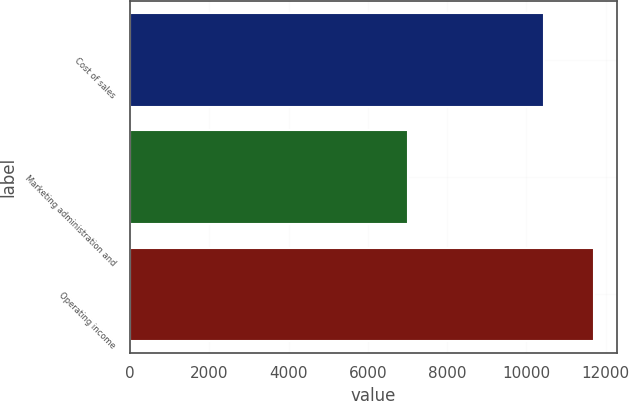Convert chart. <chart><loc_0><loc_0><loc_500><loc_500><bar_chart><fcel>Cost of sales<fcel>Marketing administration and<fcel>Operating income<nl><fcel>10436<fcel>7001<fcel>11702<nl></chart> 